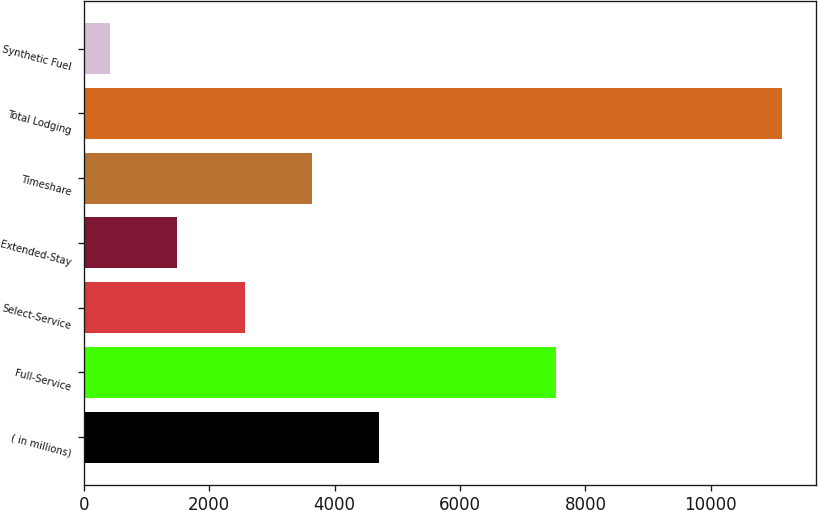Convert chart to OTSL. <chart><loc_0><loc_0><loc_500><loc_500><bar_chart><fcel>( in millions)<fcel>Full-Service<fcel>Select-Service<fcel>Extended-Stay<fcel>Timeshare<fcel>Total Lodging<fcel>Synthetic Fuel<nl><fcel>4704.2<fcel>7535<fcel>2562.6<fcel>1491.8<fcel>3633.4<fcel>11129<fcel>421<nl></chart> 